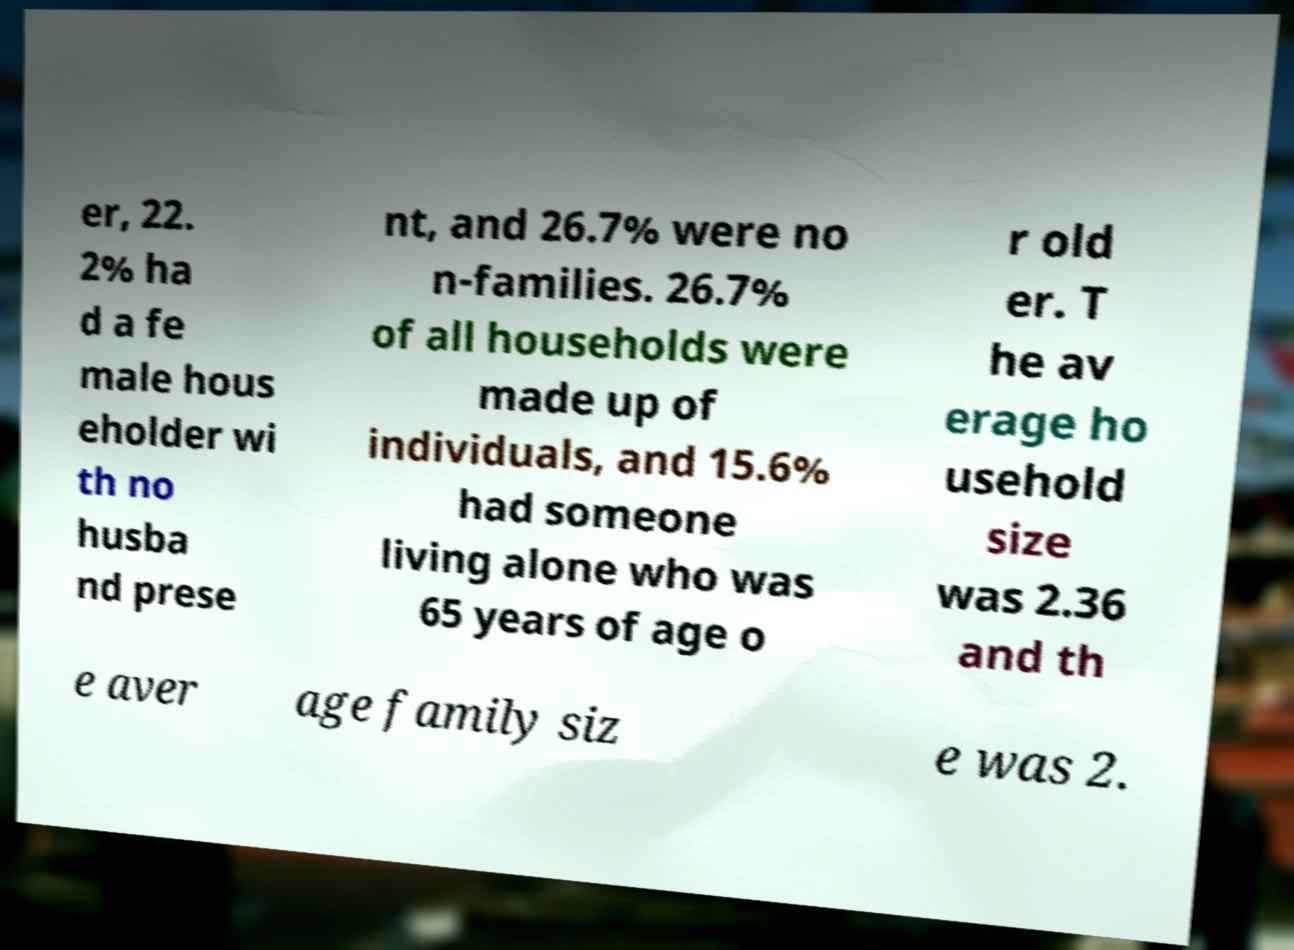Could you extract and type out the text from this image? er, 22. 2% ha d a fe male hous eholder wi th no husba nd prese nt, and 26.7% were no n-families. 26.7% of all households were made up of individuals, and 15.6% had someone living alone who was 65 years of age o r old er. T he av erage ho usehold size was 2.36 and th e aver age family siz e was 2. 